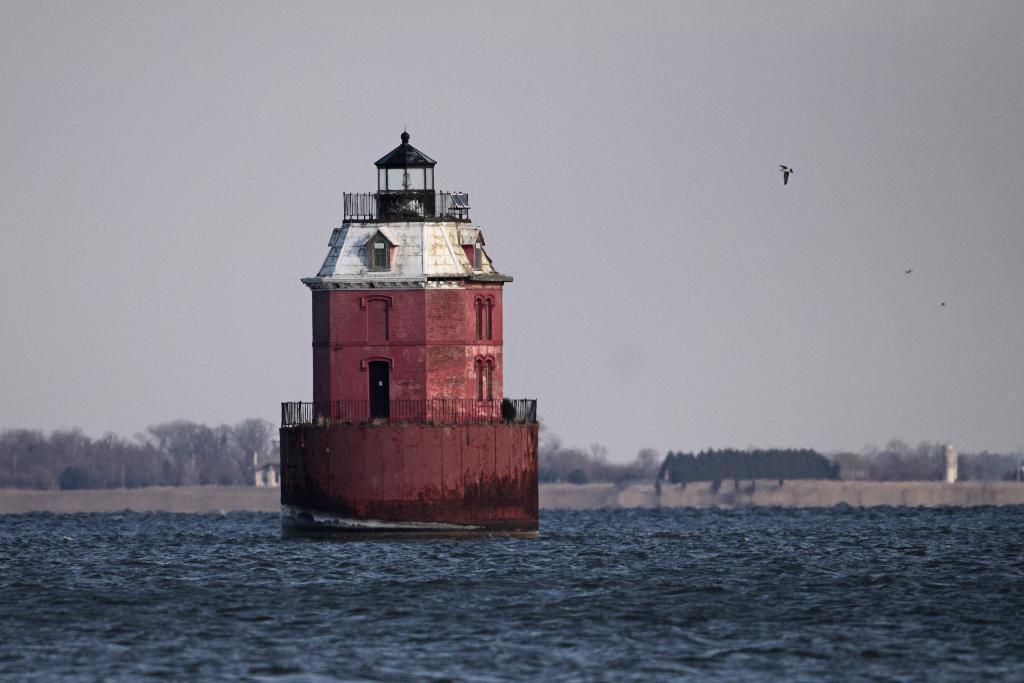Could you give a brief overview of what you see in this image? In this picture we can see water at the bottom, there is a lighthouse here, in the background there are some trees, we can see the sky at the top of the picture. 